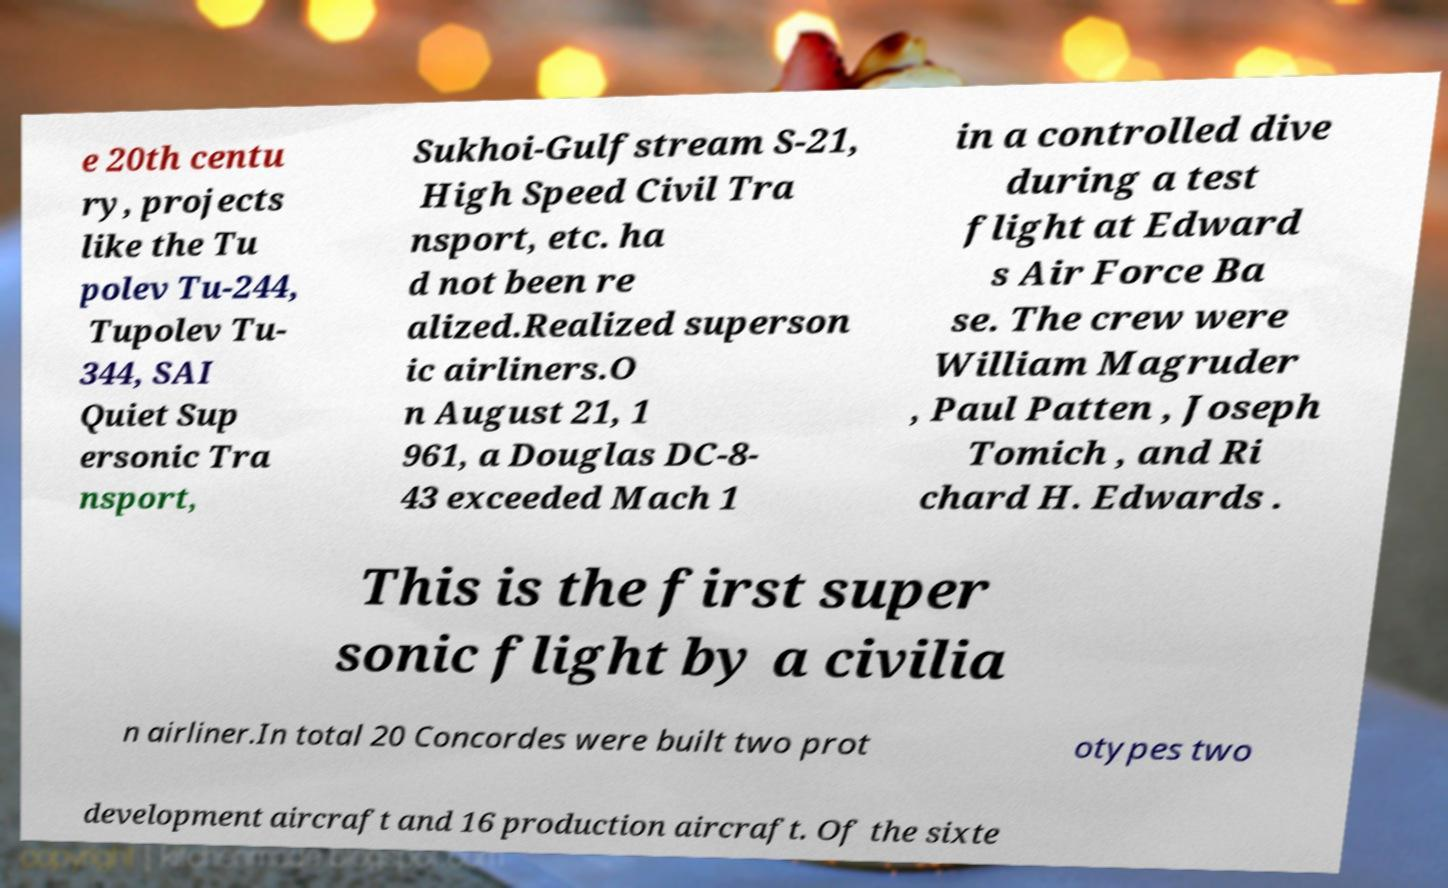Please identify and transcribe the text found in this image. e 20th centu ry, projects like the Tu polev Tu-244, Tupolev Tu- 344, SAI Quiet Sup ersonic Tra nsport, Sukhoi-Gulfstream S-21, High Speed Civil Tra nsport, etc. ha d not been re alized.Realized superson ic airliners.O n August 21, 1 961, a Douglas DC-8- 43 exceeded Mach 1 in a controlled dive during a test flight at Edward s Air Force Ba se. The crew were William Magruder , Paul Patten , Joseph Tomich , and Ri chard H. Edwards . This is the first super sonic flight by a civilia n airliner.In total 20 Concordes were built two prot otypes two development aircraft and 16 production aircraft. Of the sixte 